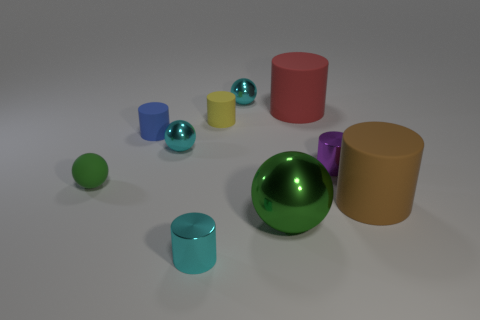There is a yellow rubber object that is the same shape as the red thing; what size is it?
Your answer should be compact. Small. Is the size of the brown cylinder the same as the blue cylinder?
Provide a short and direct response. No. What shape is the large rubber object left of the matte object that is right of the metal cylinder that is behind the big brown matte cylinder?
Provide a succinct answer. Cylinder. What color is the other small matte object that is the same shape as the small blue object?
Your response must be concise. Yellow. There is a shiny sphere that is on the right side of the yellow rubber cylinder and behind the large brown cylinder; how big is it?
Make the answer very short. Small. What number of large balls are to the right of the metallic cylinder that is on the right side of the tiny cyan thing behind the red thing?
Provide a short and direct response. 0. What number of large objects are cyan metallic spheres or yellow spheres?
Your answer should be very brief. 0. Are the tiny cyan ball behind the red thing and the tiny blue thing made of the same material?
Ensure brevity in your answer.  No. There is a small thing that is in front of the green ball that is in front of the green thing that is to the left of the yellow matte thing; what is its material?
Ensure brevity in your answer.  Metal. What number of matte objects are big green things or tiny blue blocks?
Your response must be concise. 0. 